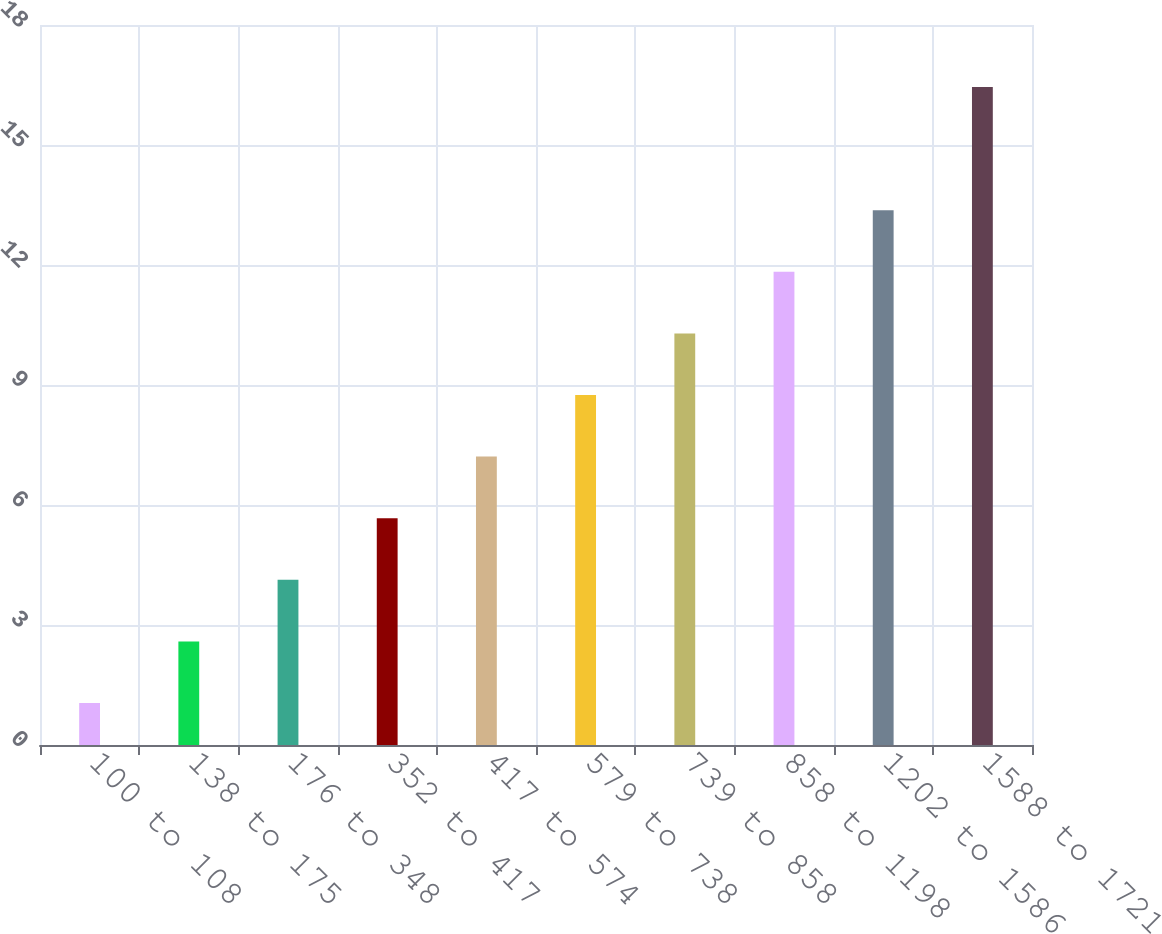Convert chart. <chart><loc_0><loc_0><loc_500><loc_500><bar_chart><fcel>100 to 108<fcel>138 to 175<fcel>176 to 348<fcel>352 to 417<fcel>417 to 574<fcel>579 to 738<fcel>739 to 858<fcel>858 to 1198<fcel>1202 to 1586<fcel>1588 to 1721<nl><fcel>1.05<fcel>2.59<fcel>4.13<fcel>5.67<fcel>7.21<fcel>8.75<fcel>10.29<fcel>11.83<fcel>13.37<fcel>16.45<nl></chart> 